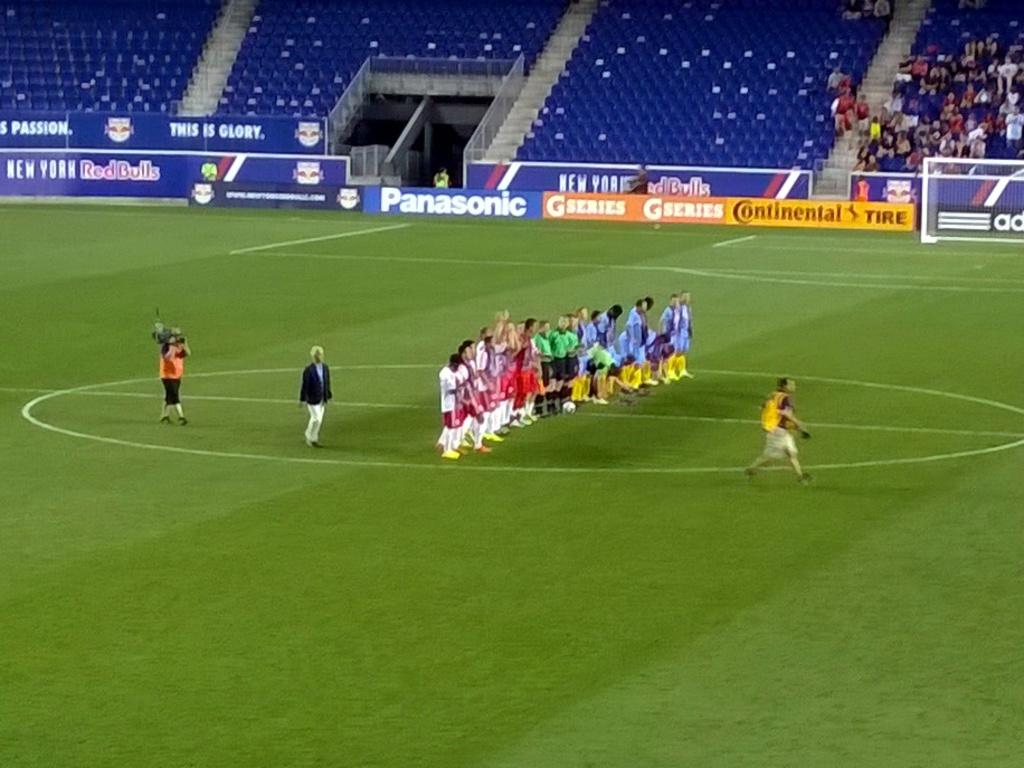What brand is advertised?
Make the answer very short. Panasonic. What drink is advertised in the background?
Give a very brief answer. Red bull. 